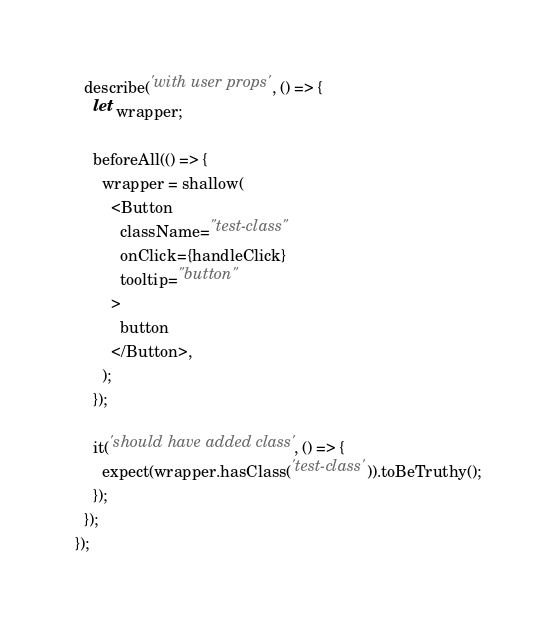Convert code to text. <code><loc_0><loc_0><loc_500><loc_500><_JavaScript_>
  describe('with user props', () => {
    let wrapper;

    beforeAll(() => {
      wrapper = shallow(
        <Button
          className="test-class"
          onClick={handleClick}
          tooltip="button"
        >
          button
        </Button>,
      );
    });

    it('should have added class', () => {
      expect(wrapper.hasClass('test-class')).toBeTruthy();
    });
  });
});
</code> 